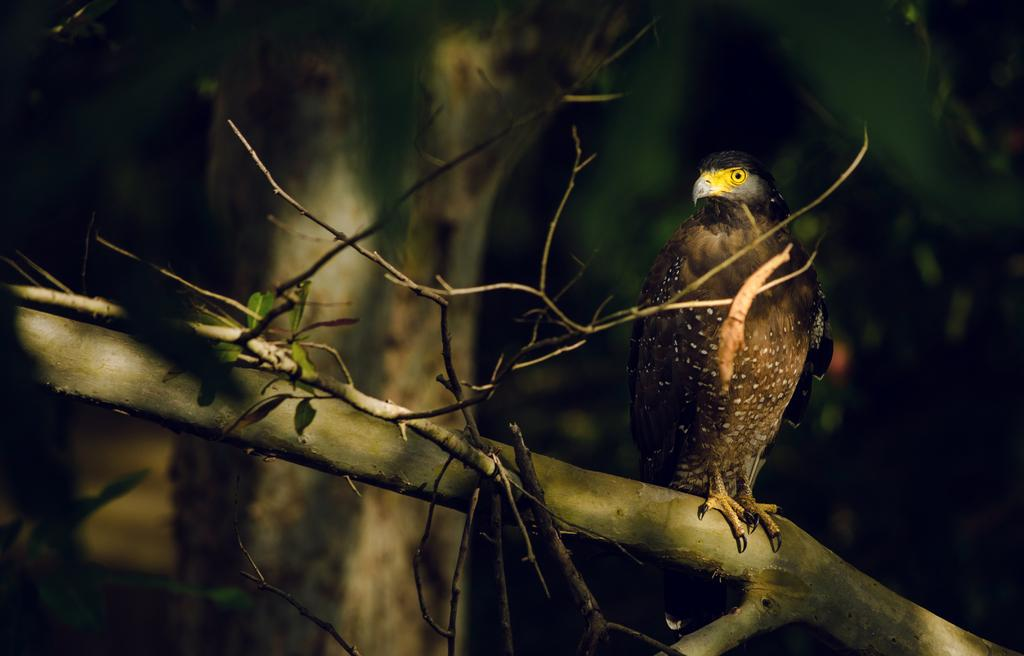What type of animal is in the image? There is a bird in the image. Where is the bird located? The bird is standing on a branch. What can be seen on the left side of the image? There are green leaves on the left side of the image. What is visible in the background of the image? There is a tree visible in the background of the image. What type of guide is the bird holding in the image? There is no guide present in the image; the bird is simply standing on a branch. 